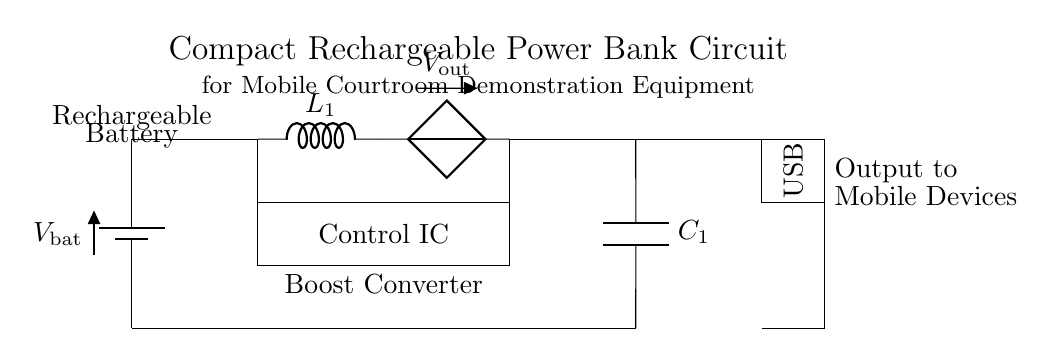What type of battery is used? The circuit diagram indicates the use of a rechargeable battery component labeled as "Rechargeable Battery" at the top left.
Answer: Rechargeable What is the function of the control IC? The control integrated circuit manages the power flow from the battery to the output, indicated by its inclusion in the circuit between the battery and the converter, along with its label.
Answer: Power management What does C1 represent in the circuit? C1 is labeled as a capacitor in the circuit and is placed at the output connection point, serving to smooth the output voltage.
Answer: Capacitor How many components are connected to the output? The output connection shows two components: the capacitor and the USB output labeled as "USB," thus a total of two components are connected.
Answer: Two What is the purpose of the inductor in this circuit? The inductor, identified as L1, is used in the circuit as part of the boost converter to step up the voltage for output, indicated by its placement in the circuit flow.
Answer: Voltage boost What voltage is indicated at the output? The output voltage is labeled as "V_out" in the circuit diagram, suggesting that it's the specified voltage delivered to the connected devices.
Answer: V_out What type of output does this circuit provide? The circuit specifies a USB output, indicated by the label "USB," for connecting to mobile devices as the final destination for the power.
Answer: USB 